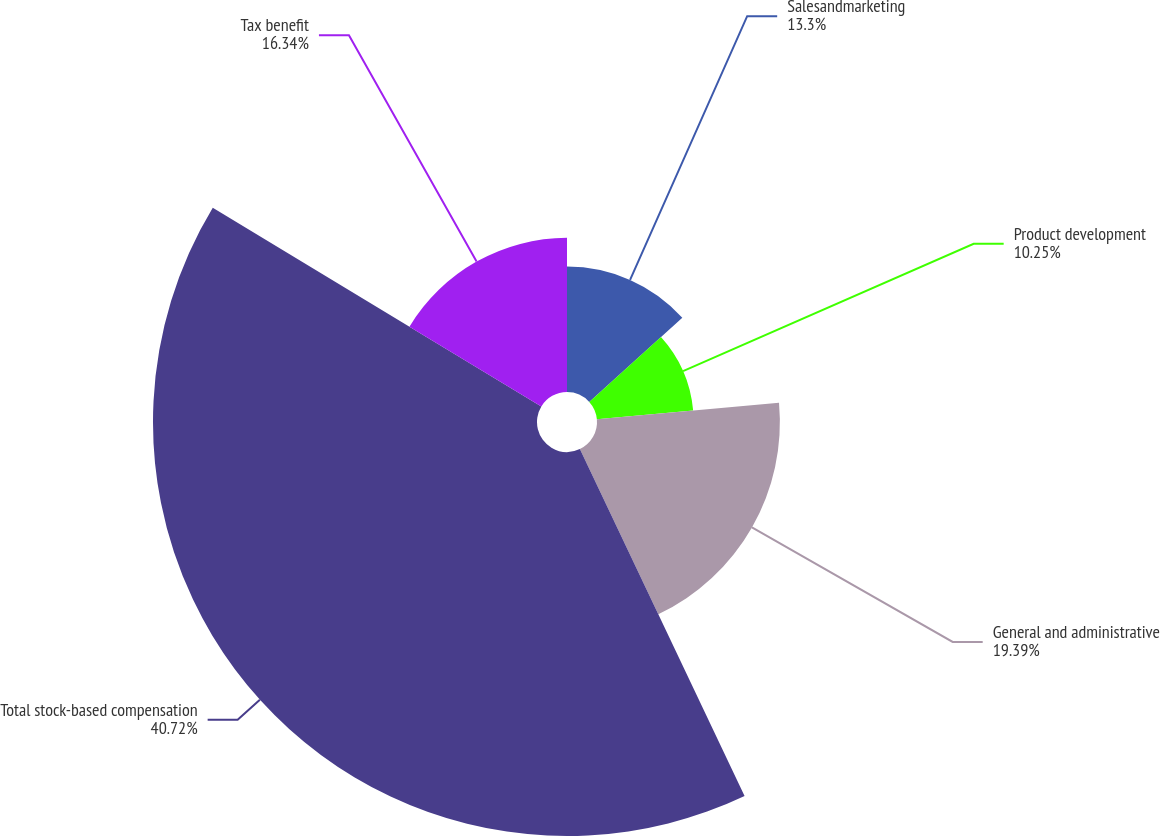Convert chart to OTSL. <chart><loc_0><loc_0><loc_500><loc_500><pie_chart><fcel>Salesandmarketing<fcel>Product development<fcel>General and administrative<fcel>Total stock-based compensation<fcel>Tax benefit<nl><fcel>13.3%<fcel>10.25%<fcel>19.39%<fcel>40.71%<fcel>16.34%<nl></chart> 